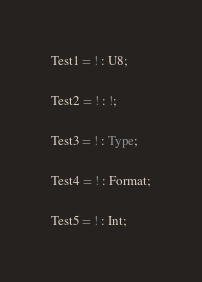Convert code to text. <code><loc_0><loc_0><loc_500><loc_500><_SQL_>Test1 = ! : U8;

Test2 = ! : !;

Test3 = ! : Type;

Test4 = ! : Format;

Test5 = ! : Int;
</code> 